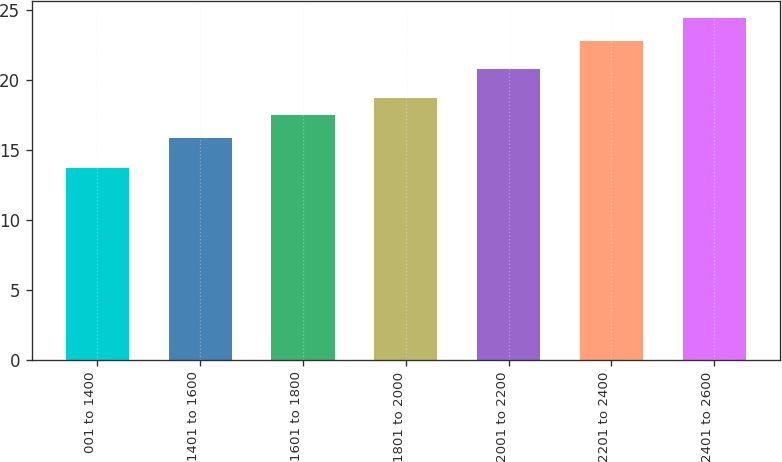<chart> <loc_0><loc_0><loc_500><loc_500><bar_chart><fcel>001 to 1400<fcel>1401 to 1600<fcel>1601 to 1800<fcel>1801 to 2000<fcel>2001 to 2200<fcel>2201 to 2400<fcel>2401 to 2600<nl><fcel>13.68<fcel>15.86<fcel>17.46<fcel>18.71<fcel>20.76<fcel>22.76<fcel>24.39<nl></chart> 